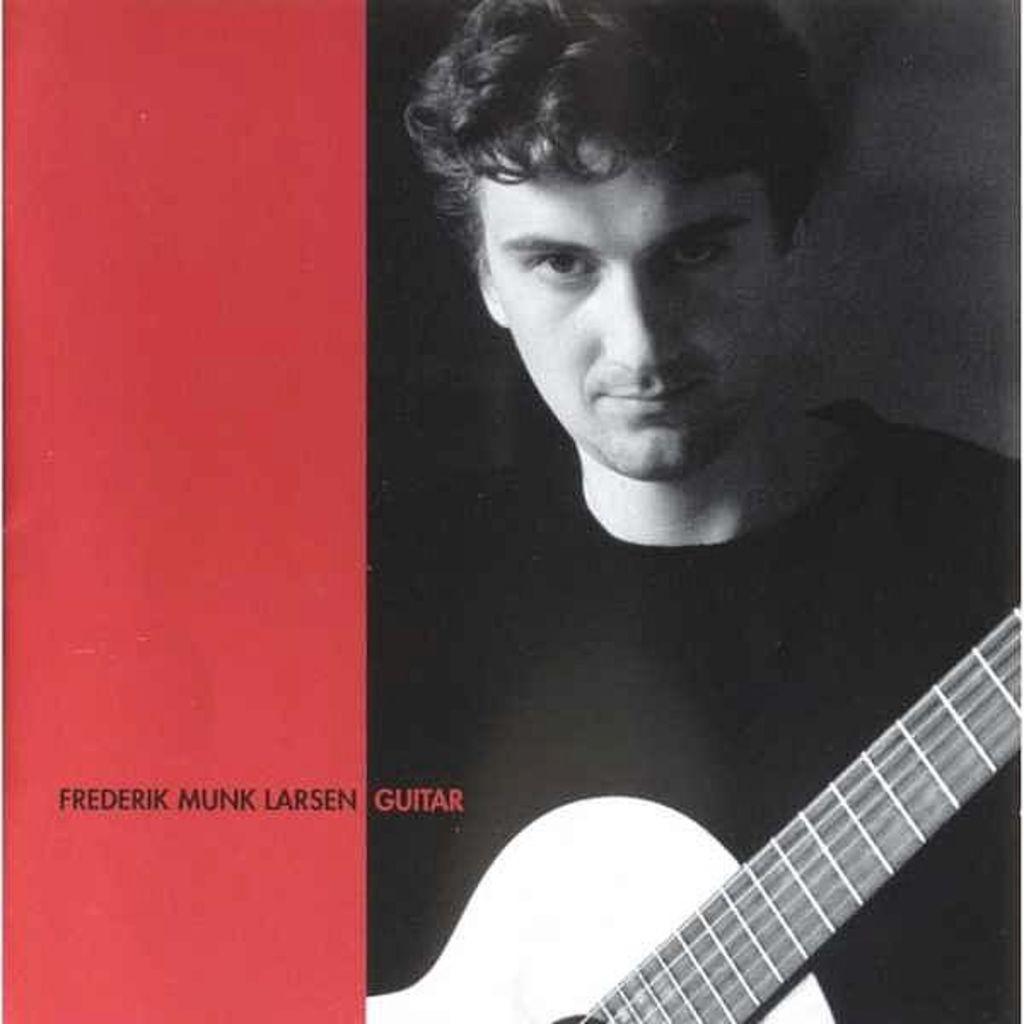Describe this image in one or two sentences. This is a poster. In this we can see a person with guitar on the right side. On the left side there is red color with something written on that. 